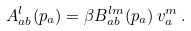Convert formula to latex. <formula><loc_0><loc_0><loc_500><loc_500>A _ { a b } ^ { l } ( { p } _ { a } ) = \beta B _ { a b } ^ { l m } ( { p } _ { a } ) \, v _ { a } ^ { m } \, .</formula> 